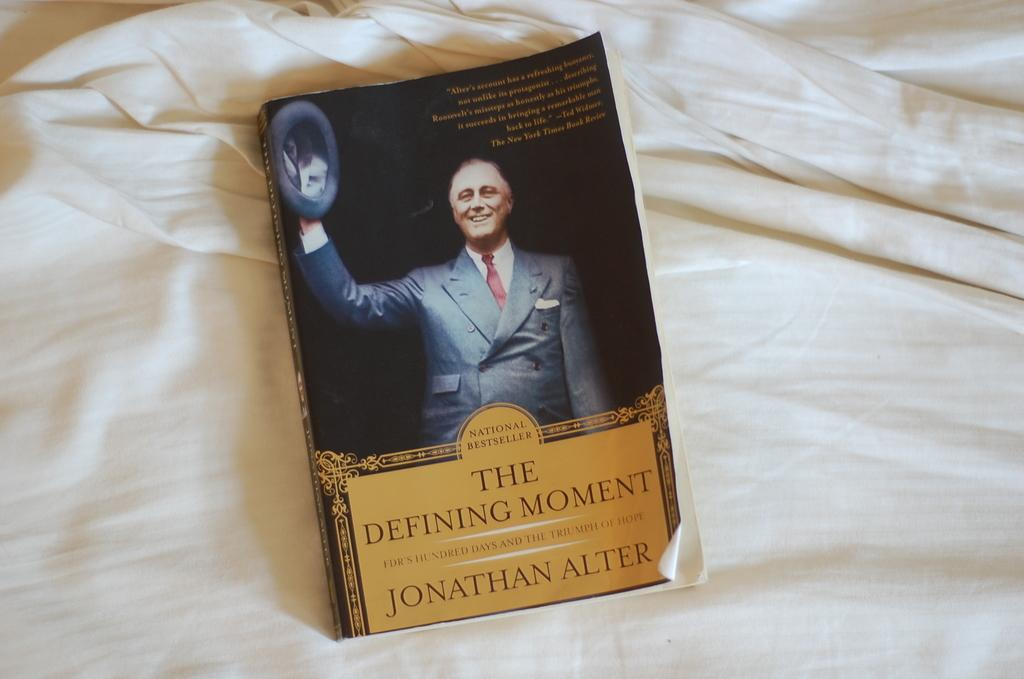<image>
Describe the image concisely. Jonathan Alter's "Defining Moment, FDR's Hundred Days and the Triumph of Hope" is available in paperback. 